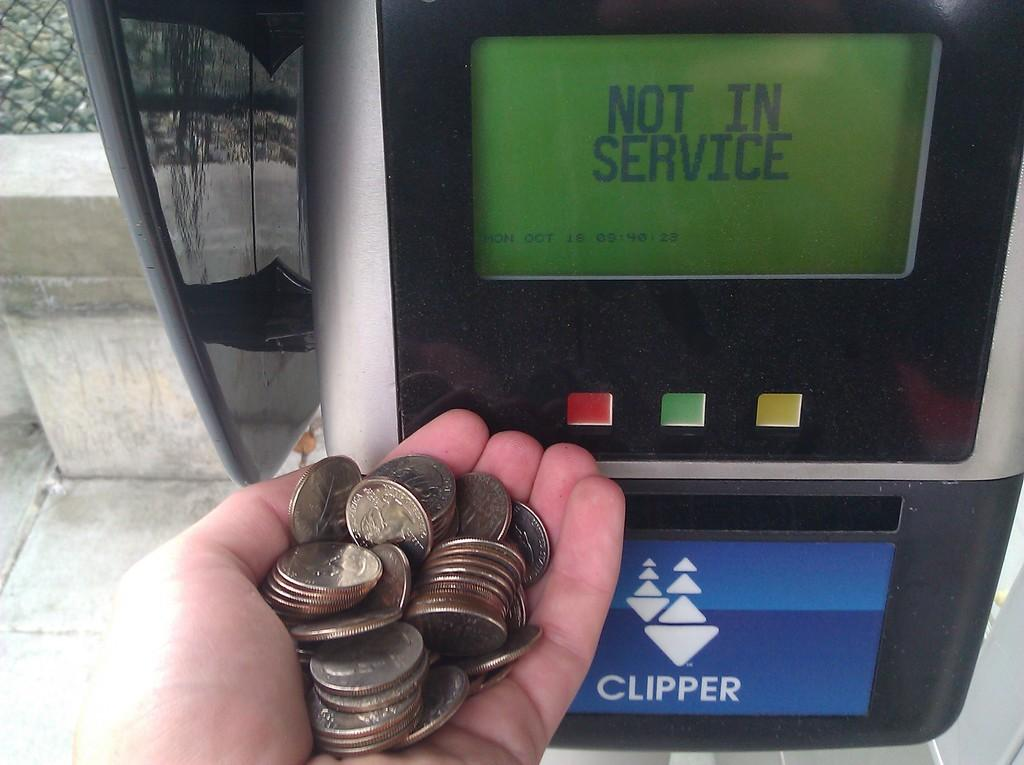<image>
Share a concise interpretation of the image provided. A person with a handful of coins by a meter that is out of service. 